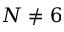Convert formula to latex. <formula><loc_0><loc_0><loc_500><loc_500>N \ne 6</formula> 